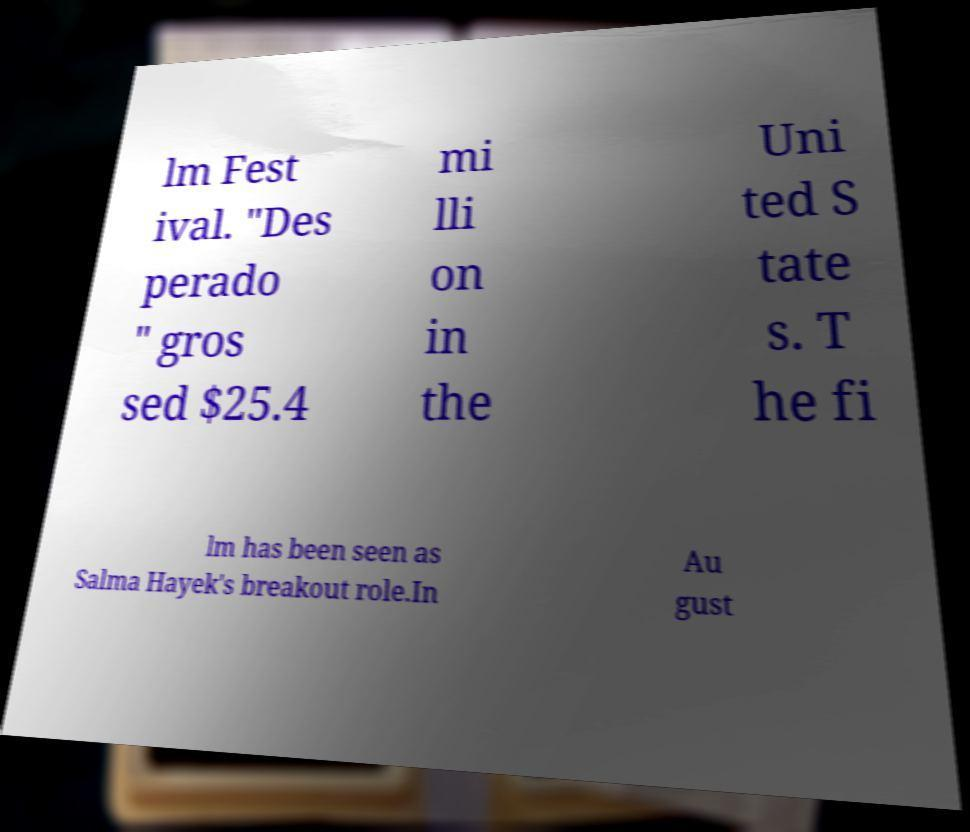Could you extract and type out the text from this image? lm Fest ival. "Des perado " gros sed $25.4 mi lli on in the Uni ted S tate s. T he fi lm has been seen as Salma Hayek's breakout role.In Au gust 